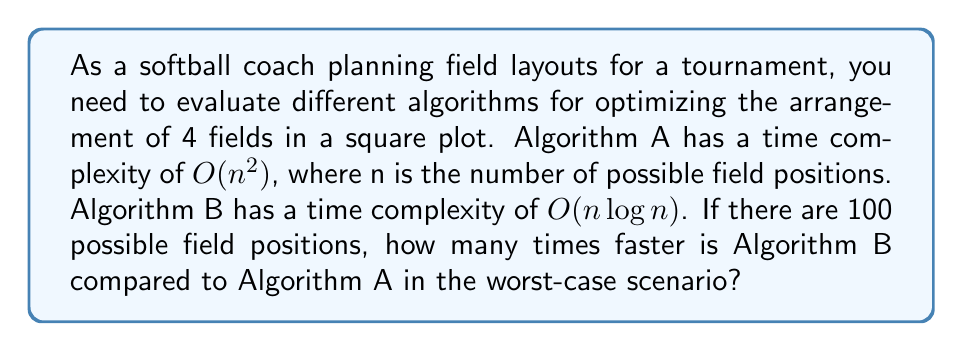Can you solve this math problem? To solve this problem, we need to compare the worst-case time complexities of both algorithms:

1. Algorithm A: $O(n^2)$
2. Algorithm B: $O(n \log n)$

Given that $n = 100$ (possible field positions), let's calculate the relative efficiency:

For Algorithm A:
$$ T_A = c_1 \cdot n^2 = c_1 \cdot 100^2 = 10000c_1 $$

For Algorithm B:
$$ T_B = c_2 \cdot n \log n = c_2 \cdot 100 \log 100 \approx 200c_2 $$

Assuming the constant factors $c_1$ and $c_2$ are approximately equal, we can compare the algorithms by dividing their time complexities:

$$ \frac{T_A}{T_B} = \frac{10000c_1}{200c_2} \approx \frac{10000}{200} = 50 $$

This means that Algorithm B is approximately 50 times faster than Algorithm A in the worst-case scenario for $n = 100$.
Answer: Algorithm B is approximately 50 times faster than Algorithm A for optimizing the layout of 4 softball fields with 100 possible field positions. 